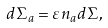Convert formula to latex. <formula><loc_0><loc_0><loc_500><loc_500>d \Sigma _ { a } = \varepsilon n _ { a } d \Sigma ,</formula> 